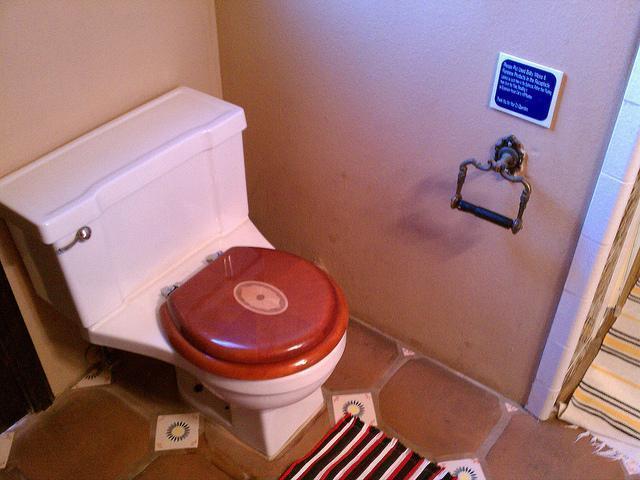How many rugs are laying on the floor?
Give a very brief answer. 2. 